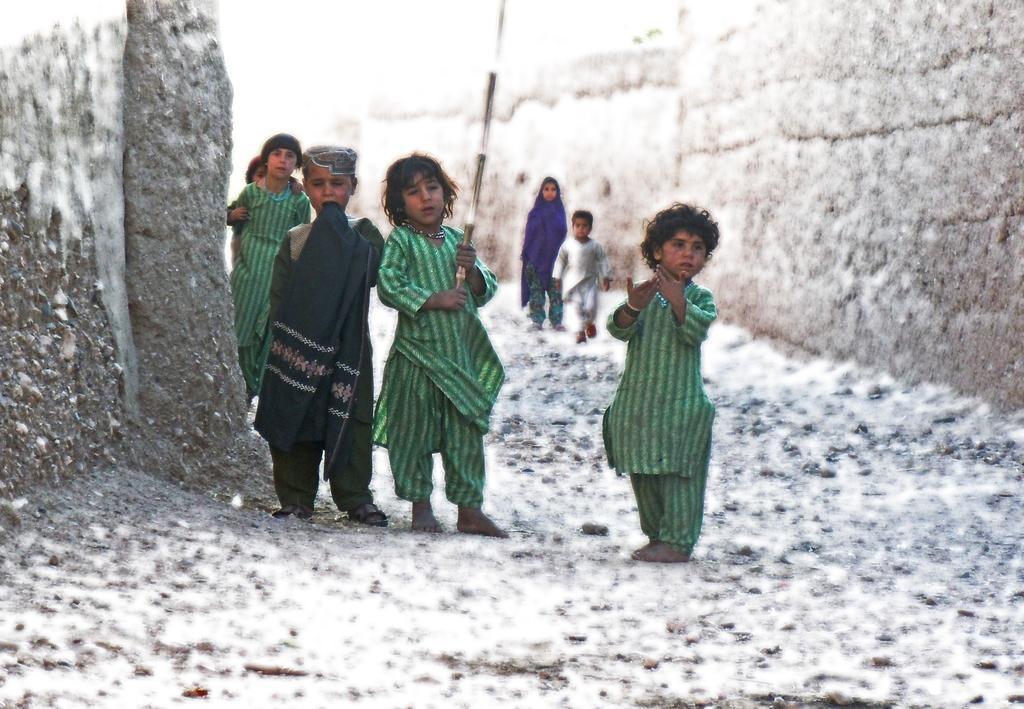How would you summarize this image in a sentence or two? In this image there are children's standing and walking on the surface, one of them is holding a stick in her hand. On the right and left side of the image there are walls. 